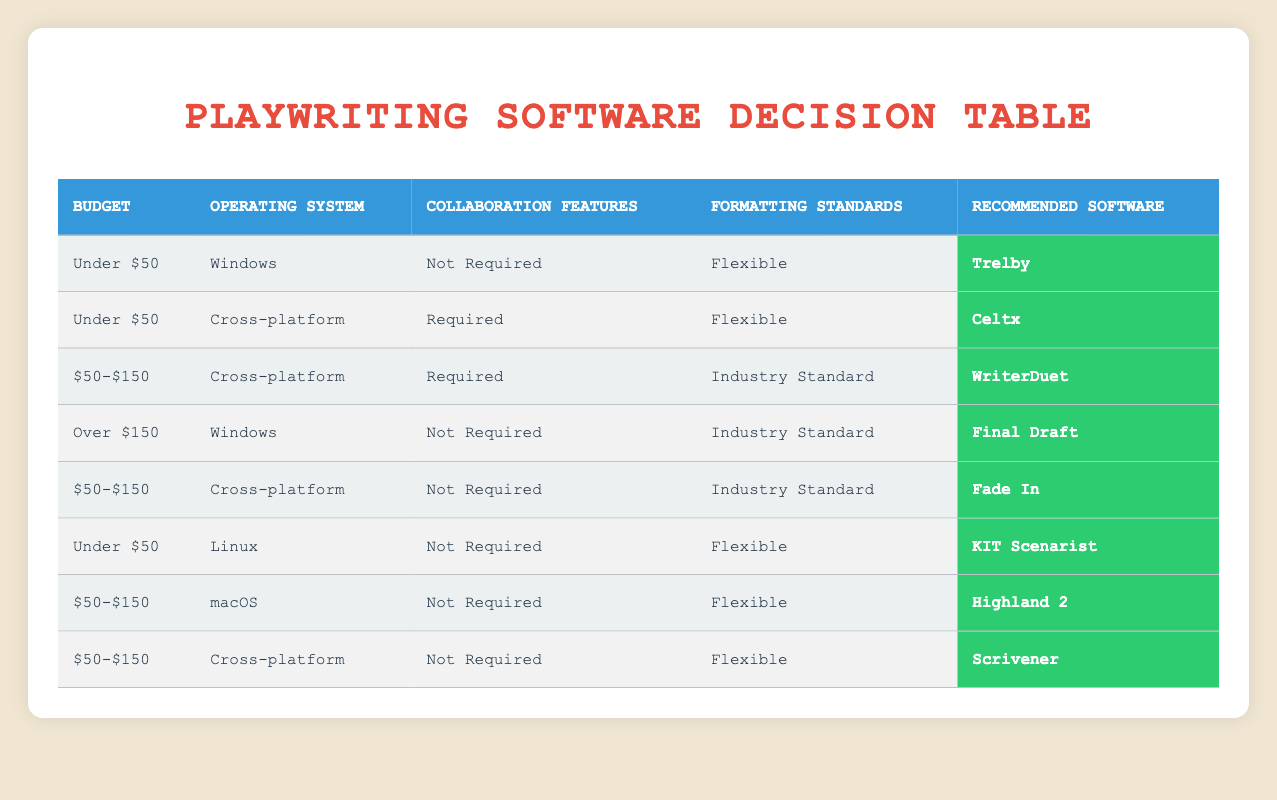What playwriting software is recommended for a budget under $50, on Windows, with no collaboration features, and flexible formatting standards? Looking at the table under the specified conditions: "Under $50", "Windows", "Not Required", and "Flexible", the recommended software listed is "Trelby".
Answer: Trelby Which software is suggested for a budget between $50 and $150, requiring collaboration, and running on a cross-platform system with industry-standard formatting? The relevant conditions are "$50-$150", "Cross-platform", "Required", and "Industry Standard". Based on the table, the software that fits is "WriterDuet".
Answer: WriterDuet Is "Fade In" compatible with a budget of $50-$150 and a requirement for no collaboration features? By examining the conditions, "Fade In" fits the budget of "$50-$150" and has "Not Required" for collaboration features while also being compatible with "Cross-platform" and "Industry Standard". Thus, the answer is yes.
Answer: Yes What is the software recommended for users with a Linux operating system, who prefer a budget under $50 and do not require collaboration features, while being flexible with formatting standards? The conditions here are "Under $50", "Linux", "Not Required", and "Flexible". Referring to the table, the software recommended is "KIT Scenarist".
Answer: KIT Scenarist For users seeking software that costs over $150, is on Windows, does not require collaboration, and adheres to industry standards, what is the recommendation? According to the table, under these conditions: "Over $150", "Windows", "Not Required", and "Industry Standard", the recommended software is "Final Draft".
Answer: Final Draft How many software options are available that meet the criteria of cross-platform, requiring collaboration features, and costing over $150? The table shows no entries that meet the criteria of "Over $150" and "Required" collaboration features given that all relevant software listed is under or has restrictions.
Answer: 0 What is the recommended playwriting software for users on macOS with a budget of $50-$150 and requiring no collaboration features under flexible formatting? The specified conditions are "$50-$150", "macOS", "Not Required", and "Flexible". According to the table, the recommended software is "Highland 2".
Answer: Highland 2 Identify the playwriting software options available for a flexible formatting need with no collaboration features within the $50-$150 budget that also supports macOS and cross-platform operating systems. Under the conditions of "$50-$150", "Not Required" for collaboration, "Flexible" formatting, macOS gives us "Highland 2", while cross-platform allows us "Scrivener" and "Fade In", making a total of three options.
Answer: 3 